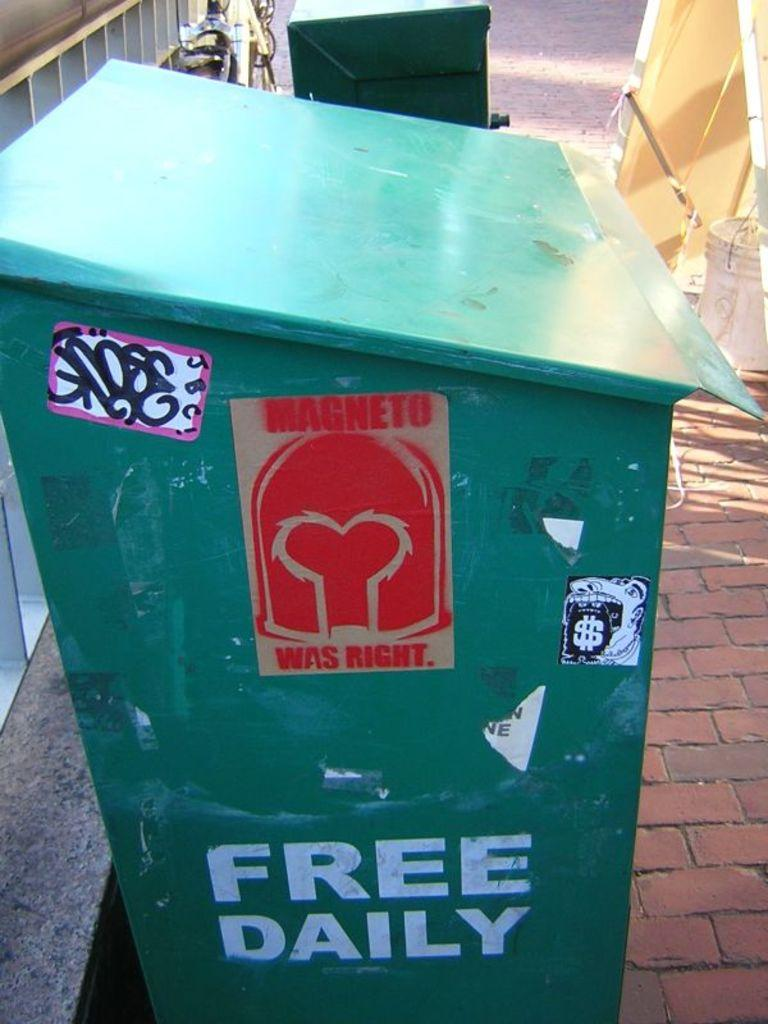<image>
Give a short and clear explanation of the subsequent image. a green dumpster with FREE DAILY on the bottom 